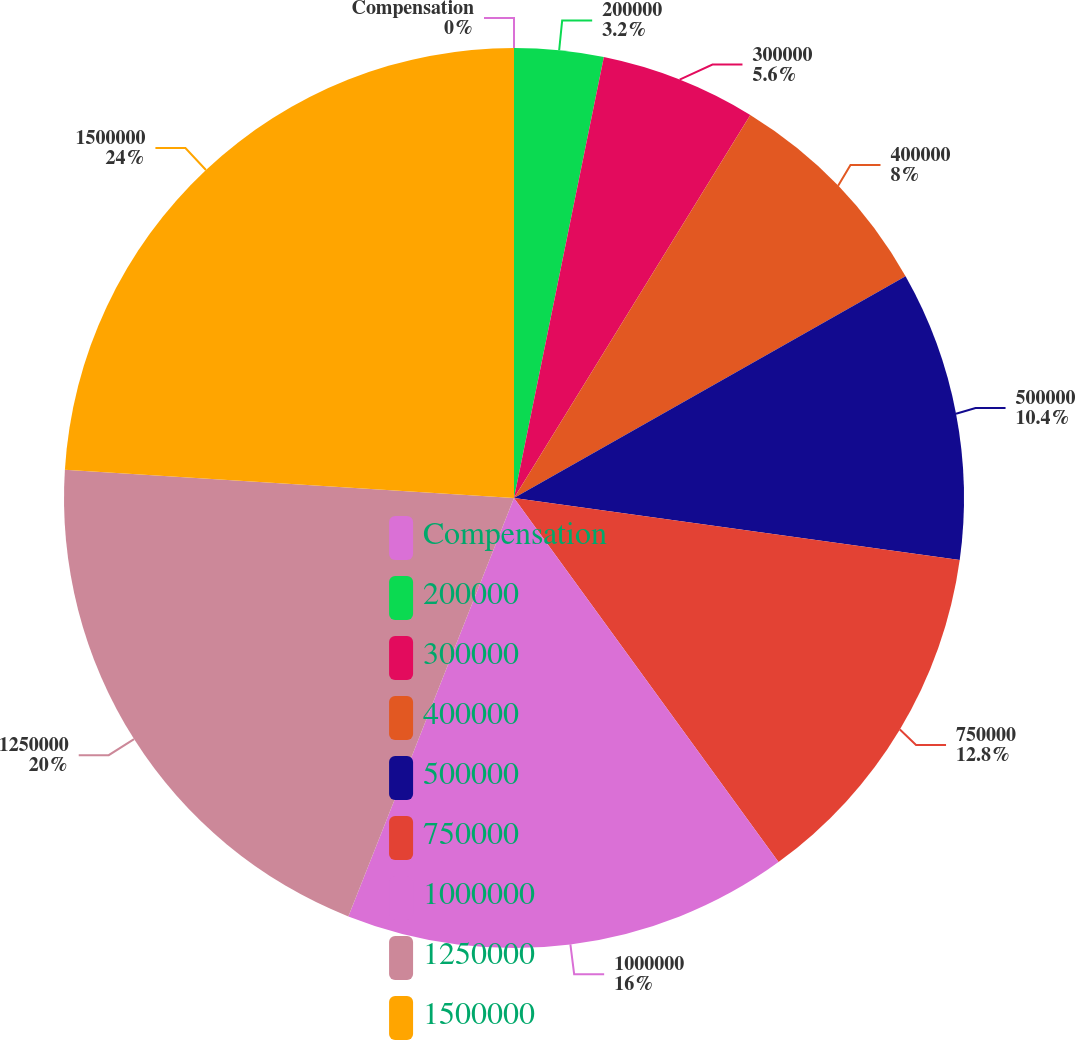Convert chart. <chart><loc_0><loc_0><loc_500><loc_500><pie_chart><fcel>Compensation<fcel>200000<fcel>300000<fcel>400000<fcel>500000<fcel>750000<fcel>1000000<fcel>1250000<fcel>1500000<nl><fcel>0.0%<fcel>3.2%<fcel>5.6%<fcel>8.0%<fcel>10.4%<fcel>12.8%<fcel>16.0%<fcel>20.0%<fcel>24.0%<nl></chart> 